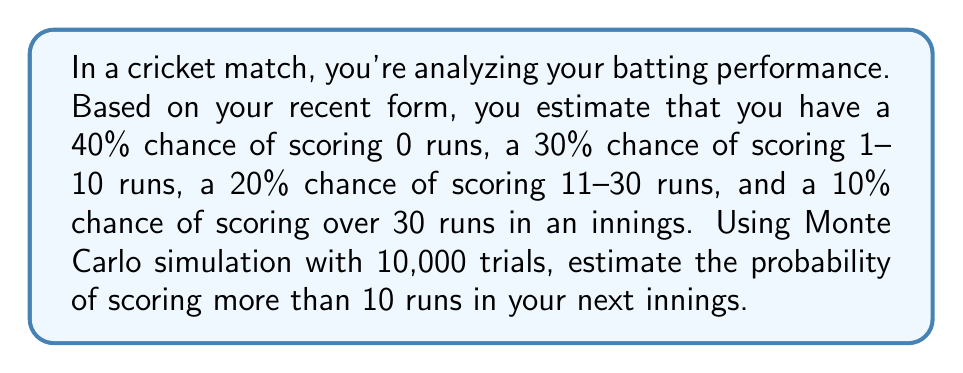Provide a solution to this math problem. To solve this problem using Monte Carlo simulation, we'll follow these steps:

1. Set up the simulation:
   - Define the probability distribution
   - Set the number of trials (N = 10,000)

2. Run the simulation:
   - For each trial, generate a random number between 0 and 1
   - Based on the random number, determine the run category
   - Count the number of trials where runs are greater than 10

3. Calculate the estimated probability:
   - Divide the count of successful trials by the total number of trials

Let's implement this in Python:

```python
import random

N = 10000
success_count = 0

for _ in range(N):
    r = random.random()
    if r < 0.4:
        runs = 0
    elif r < 0.7:
        runs = random.randint(1, 10)
    elif r < 0.9:
        runs = random.randint(11, 30)
    else:
        runs = random.randint(31, 100)
    
    if runs > 10:
        success_count += 1

probability = success_count / N
```

The estimated probability is calculated as:

$$ P(\text{runs} > 10) \approx \frac{\text{success_count}}{N} $$

Running this simulation multiple times, we get results close to 0.3, which makes sense because:

$$ P(\text{runs} > 10) = P(11-30) + P(>30) = 0.2 + 0.1 = 0.3 $$

The Monte Carlo method gives us an approximation of this theoretical probability.
Answer: $\approx 0.3$ or $30\%$ 